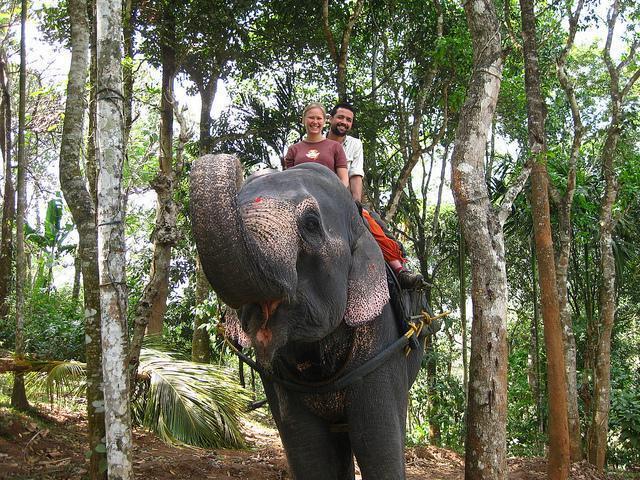How many people are sitting on the elephant?
Give a very brief answer. 2. How many people are on the elephant?
Give a very brief answer. 2. How many elephants are there?
Give a very brief answer. 1. How many people can you see?
Give a very brief answer. 2. How many dark umbrellas are there?
Give a very brief answer. 0. 